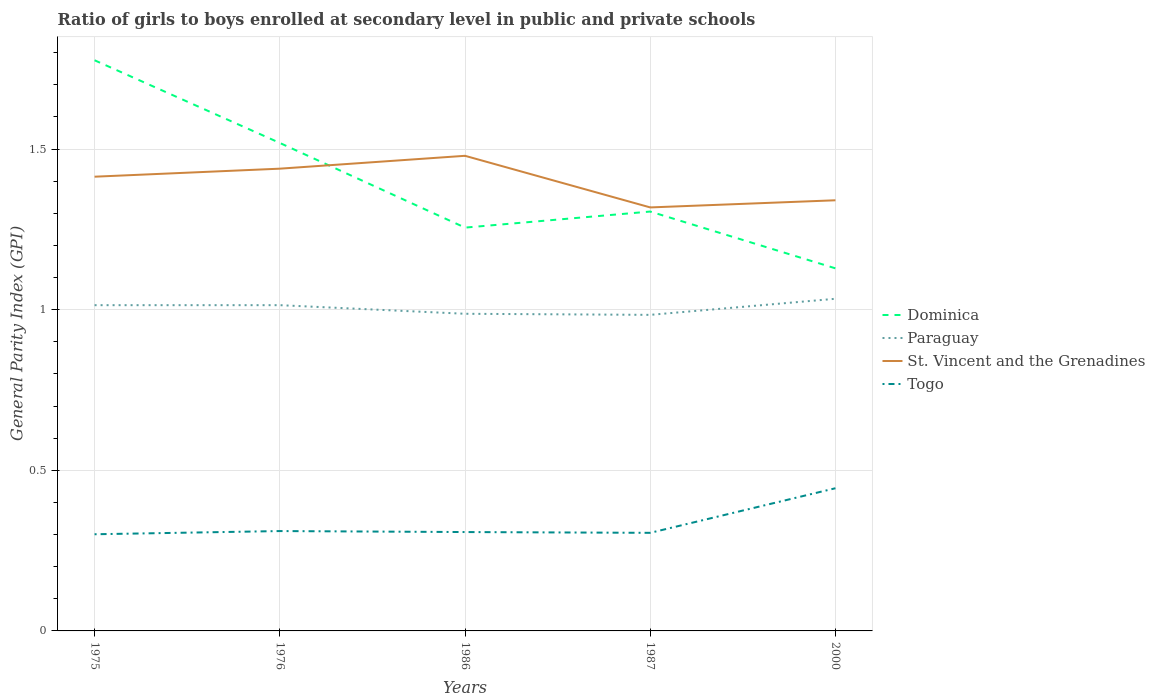Does the line corresponding to Paraguay intersect with the line corresponding to St. Vincent and the Grenadines?
Provide a short and direct response. No. Is the number of lines equal to the number of legend labels?
Ensure brevity in your answer.  Yes. Across all years, what is the maximum general parity index in Dominica?
Make the answer very short. 1.13. What is the total general parity index in Togo in the graph?
Make the answer very short. 0. What is the difference between the highest and the second highest general parity index in Togo?
Your answer should be compact. 0.14. Is the general parity index in Togo strictly greater than the general parity index in Paraguay over the years?
Ensure brevity in your answer.  Yes. How many lines are there?
Offer a very short reply. 4. How many years are there in the graph?
Keep it short and to the point. 5. Are the values on the major ticks of Y-axis written in scientific E-notation?
Your answer should be compact. No. Does the graph contain grids?
Make the answer very short. Yes. Where does the legend appear in the graph?
Keep it short and to the point. Center right. How many legend labels are there?
Give a very brief answer. 4. How are the legend labels stacked?
Provide a succinct answer. Vertical. What is the title of the graph?
Your answer should be very brief. Ratio of girls to boys enrolled at secondary level in public and private schools. What is the label or title of the Y-axis?
Offer a terse response. General Parity Index (GPI). What is the General Parity Index (GPI) in Dominica in 1975?
Keep it short and to the point. 1.78. What is the General Parity Index (GPI) in Paraguay in 1975?
Your answer should be compact. 1.01. What is the General Parity Index (GPI) of St. Vincent and the Grenadines in 1975?
Offer a very short reply. 1.41. What is the General Parity Index (GPI) of Togo in 1975?
Keep it short and to the point. 0.3. What is the General Parity Index (GPI) of Dominica in 1976?
Your answer should be compact. 1.52. What is the General Parity Index (GPI) in Paraguay in 1976?
Provide a short and direct response. 1.01. What is the General Parity Index (GPI) in St. Vincent and the Grenadines in 1976?
Keep it short and to the point. 1.44. What is the General Parity Index (GPI) of Togo in 1976?
Ensure brevity in your answer.  0.31. What is the General Parity Index (GPI) in Dominica in 1986?
Your response must be concise. 1.26. What is the General Parity Index (GPI) of Paraguay in 1986?
Your answer should be very brief. 0.99. What is the General Parity Index (GPI) in St. Vincent and the Grenadines in 1986?
Provide a short and direct response. 1.48. What is the General Parity Index (GPI) of Togo in 1986?
Provide a succinct answer. 0.31. What is the General Parity Index (GPI) in Dominica in 1987?
Provide a short and direct response. 1.31. What is the General Parity Index (GPI) in Paraguay in 1987?
Offer a terse response. 0.98. What is the General Parity Index (GPI) of St. Vincent and the Grenadines in 1987?
Your answer should be compact. 1.32. What is the General Parity Index (GPI) in Togo in 1987?
Offer a very short reply. 0.31. What is the General Parity Index (GPI) in Dominica in 2000?
Your answer should be very brief. 1.13. What is the General Parity Index (GPI) of Paraguay in 2000?
Keep it short and to the point. 1.03. What is the General Parity Index (GPI) of St. Vincent and the Grenadines in 2000?
Offer a terse response. 1.34. What is the General Parity Index (GPI) in Togo in 2000?
Offer a terse response. 0.44. Across all years, what is the maximum General Parity Index (GPI) of Dominica?
Make the answer very short. 1.78. Across all years, what is the maximum General Parity Index (GPI) in Paraguay?
Your answer should be compact. 1.03. Across all years, what is the maximum General Parity Index (GPI) of St. Vincent and the Grenadines?
Your answer should be very brief. 1.48. Across all years, what is the maximum General Parity Index (GPI) in Togo?
Your answer should be very brief. 0.44. Across all years, what is the minimum General Parity Index (GPI) in Dominica?
Give a very brief answer. 1.13. Across all years, what is the minimum General Parity Index (GPI) of Paraguay?
Your answer should be very brief. 0.98. Across all years, what is the minimum General Parity Index (GPI) of St. Vincent and the Grenadines?
Keep it short and to the point. 1.32. Across all years, what is the minimum General Parity Index (GPI) of Togo?
Ensure brevity in your answer.  0.3. What is the total General Parity Index (GPI) of Dominica in the graph?
Provide a short and direct response. 6.99. What is the total General Parity Index (GPI) of Paraguay in the graph?
Provide a short and direct response. 5.03. What is the total General Parity Index (GPI) in St. Vincent and the Grenadines in the graph?
Offer a very short reply. 6.99. What is the total General Parity Index (GPI) in Togo in the graph?
Offer a very short reply. 1.67. What is the difference between the General Parity Index (GPI) in Dominica in 1975 and that in 1976?
Make the answer very short. 0.26. What is the difference between the General Parity Index (GPI) of Paraguay in 1975 and that in 1976?
Offer a terse response. 0. What is the difference between the General Parity Index (GPI) of St. Vincent and the Grenadines in 1975 and that in 1976?
Offer a very short reply. -0.03. What is the difference between the General Parity Index (GPI) of Togo in 1975 and that in 1976?
Provide a short and direct response. -0.01. What is the difference between the General Parity Index (GPI) of Dominica in 1975 and that in 1986?
Your response must be concise. 0.52. What is the difference between the General Parity Index (GPI) in Paraguay in 1975 and that in 1986?
Your response must be concise. 0.03. What is the difference between the General Parity Index (GPI) in St. Vincent and the Grenadines in 1975 and that in 1986?
Provide a short and direct response. -0.07. What is the difference between the General Parity Index (GPI) in Togo in 1975 and that in 1986?
Your response must be concise. -0.01. What is the difference between the General Parity Index (GPI) of Dominica in 1975 and that in 1987?
Give a very brief answer. 0.47. What is the difference between the General Parity Index (GPI) of Paraguay in 1975 and that in 1987?
Offer a terse response. 0.03. What is the difference between the General Parity Index (GPI) in St. Vincent and the Grenadines in 1975 and that in 1987?
Your answer should be very brief. 0.1. What is the difference between the General Parity Index (GPI) in Togo in 1975 and that in 1987?
Your response must be concise. -0. What is the difference between the General Parity Index (GPI) in Dominica in 1975 and that in 2000?
Provide a short and direct response. 0.65. What is the difference between the General Parity Index (GPI) of Paraguay in 1975 and that in 2000?
Give a very brief answer. -0.02. What is the difference between the General Parity Index (GPI) in St. Vincent and the Grenadines in 1975 and that in 2000?
Ensure brevity in your answer.  0.07. What is the difference between the General Parity Index (GPI) in Togo in 1975 and that in 2000?
Make the answer very short. -0.14. What is the difference between the General Parity Index (GPI) of Dominica in 1976 and that in 1986?
Your answer should be compact. 0.26. What is the difference between the General Parity Index (GPI) of Paraguay in 1976 and that in 1986?
Your response must be concise. 0.03. What is the difference between the General Parity Index (GPI) in St. Vincent and the Grenadines in 1976 and that in 1986?
Offer a very short reply. -0.04. What is the difference between the General Parity Index (GPI) in Togo in 1976 and that in 1986?
Provide a succinct answer. 0. What is the difference between the General Parity Index (GPI) in Dominica in 1976 and that in 1987?
Provide a succinct answer. 0.21. What is the difference between the General Parity Index (GPI) in Paraguay in 1976 and that in 1987?
Offer a terse response. 0.03. What is the difference between the General Parity Index (GPI) in St. Vincent and the Grenadines in 1976 and that in 1987?
Ensure brevity in your answer.  0.12. What is the difference between the General Parity Index (GPI) in Togo in 1976 and that in 1987?
Ensure brevity in your answer.  0.01. What is the difference between the General Parity Index (GPI) of Dominica in 1976 and that in 2000?
Your answer should be compact. 0.39. What is the difference between the General Parity Index (GPI) of Paraguay in 1976 and that in 2000?
Provide a succinct answer. -0.02. What is the difference between the General Parity Index (GPI) in St. Vincent and the Grenadines in 1976 and that in 2000?
Provide a succinct answer. 0.1. What is the difference between the General Parity Index (GPI) in Togo in 1976 and that in 2000?
Ensure brevity in your answer.  -0.13. What is the difference between the General Parity Index (GPI) of Dominica in 1986 and that in 1987?
Provide a short and direct response. -0.05. What is the difference between the General Parity Index (GPI) of Paraguay in 1986 and that in 1987?
Your response must be concise. 0. What is the difference between the General Parity Index (GPI) in St. Vincent and the Grenadines in 1986 and that in 1987?
Provide a succinct answer. 0.16. What is the difference between the General Parity Index (GPI) of Togo in 1986 and that in 1987?
Offer a very short reply. 0. What is the difference between the General Parity Index (GPI) in Dominica in 1986 and that in 2000?
Offer a very short reply. 0.13. What is the difference between the General Parity Index (GPI) in Paraguay in 1986 and that in 2000?
Provide a succinct answer. -0.05. What is the difference between the General Parity Index (GPI) in St. Vincent and the Grenadines in 1986 and that in 2000?
Give a very brief answer. 0.14. What is the difference between the General Parity Index (GPI) of Togo in 1986 and that in 2000?
Your answer should be compact. -0.14. What is the difference between the General Parity Index (GPI) in Dominica in 1987 and that in 2000?
Your response must be concise. 0.18. What is the difference between the General Parity Index (GPI) in Paraguay in 1987 and that in 2000?
Your response must be concise. -0.05. What is the difference between the General Parity Index (GPI) of St. Vincent and the Grenadines in 1987 and that in 2000?
Offer a very short reply. -0.02. What is the difference between the General Parity Index (GPI) of Togo in 1987 and that in 2000?
Your answer should be compact. -0.14. What is the difference between the General Parity Index (GPI) in Dominica in 1975 and the General Parity Index (GPI) in Paraguay in 1976?
Your answer should be compact. 0.76. What is the difference between the General Parity Index (GPI) in Dominica in 1975 and the General Parity Index (GPI) in St. Vincent and the Grenadines in 1976?
Your answer should be compact. 0.34. What is the difference between the General Parity Index (GPI) of Dominica in 1975 and the General Parity Index (GPI) of Togo in 1976?
Make the answer very short. 1.47. What is the difference between the General Parity Index (GPI) in Paraguay in 1975 and the General Parity Index (GPI) in St. Vincent and the Grenadines in 1976?
Give a very brief answer. -0.42. What is the difference between the General Parity Index (GPI) of Paraguay in 1975 and the General Parity Index (GPI) of Togo in 1976?
Provide a short and direct response. 0.7. What is the difference between the General Parity Index (GPI) of St. Vincent and the Grenadines in 1975 and the General Parity Index (GPI) of Togo in 1976?
Offer a very short reply. 1.1. What is the difference between the General Parity Index (GPI) in Dominica in 1975 and the General Parity Index (GPI) in Paraguay in 1986?
Your answer should be compact. 0.79. What is the difference between the General Parity Index (GPI) of Dominica in 1975 and the General Parity Index (GPI) of St. Vincent and the Grenadines in 1986?
Keep it short and to the point. 0.3. What is the difference between the General Parity Index (GPI) in Dominica in 1975 and the General Parity Index (GPI) in Togo in 1986?
Ensure brevity in your answer.  1.47. What is the difference between the General Parity Index (GPI) of Paraguay in 1975 and the General Parity Index (GPI) of St. Vincent and the Grenadines in 1986?
Offer a terse response. -0.47. What is the difference between the General Parity Index (GPI) of Paraguay in 1975 and the General Parity Index (GPI) of Togo in 1986?
Keep it short and to the point. 0.71. What is the difference between the General Parity Index (GPI) in St. Vincent and the Grenadines in 1975 and the General Parity Index (GPI) in Togo in 1986?
Ensure brevity in your answer.  1.11. What is the difference between the General Parity Index (GPI) in Dominica in 1975 and the General Parity Index (GPI) in Paraguay in 1987?
Keep it short and to the point. 0.79. What is the difference between the General Parity Index (GPI) in Dominica in 1975 and the General Parity Index (GPI) in St. Vincent and the Grenadines in 1987?
Give a very brief answer. 0.46. What is the difference between the General Parity Index (GPI) of Dominica in 1975 and the General Parity Index (GPI) of Togo in 1987?
Make the answer very short. 1.47. What is the difference between the General Parity Index (GPI) of Paraguay in 1975 and the General Parity Index (GPI) of St. Vincent and the Grenadines in 1987?
Your answer should be compact. -0.3. What is the difference between the General Parity Index (GPI) in Paraguay in 1975 and the General Parity Index (GPI) in Togo in 1987?
Offer a terse response. 0.71. What is the difference between the General Parity Index (GPI) in St. Vincent and the Grenadines in 1975 and the General Parity Index (GPI) in Togo in 1987?
Ensure brevity in your answer.  1.11. What is the difference between the General Parity Index (GPI) of Dominica in 1975 and the General Parity Index (GPI) of Paraguay in 2000?
Provide a short and direct response. 0.74. What is the difference between the General Parity Index (GPI) in Dominica in 1975 and the General Parity Index (GPI) in St. Vincent and the Grenadines in 2000?
Make the answer very short. 0.44. What is the difference between the General Parity Index (GPI) in Dominica in 1975 and the General Parity Index (GPI) in Togo in 2000?
Your answer should be very brief. 1.33. What is the difference between the General Parity Index (GPI) of Paraguay in 1975 and the General Parity Index (GPI) of St. Vincent and the Grenadines in 2000?
Give a very brief answer. -0.33. What is the difference between the General Parity Index (GPI) of Paraguay in 1975 and the General Parity Index (GPI) of Togo in 2000?
Your answer should be compact. 0.57. What is the difference between the General Parity Index (GPI) of St. Vincent and the Grenadines in 1975 and the General Parity Index (GPI) of Togo in 2000?
Your response must be concise. 0.97. What is the difference between the General Parity Index (GPI) of Dominica in 1976 and the General Parity Index (GPI) of Paraguay in 1986?
Offer a terse response. 0.53. What is the difference between the General Parity Index (GPI) of Dominica in 1976 and the General Parity Index (GPI) of Togo in 1986?
Make the answer very short. 1.21. What is the difference between the General Parity Index (GPI) of Paraguay in 1976 and the General Parity Index (GPI) of St. Vincent and the Grenadines in 1986?
Make the answer very short. -0.47. What is the difference between the General Parity Index (GPI) of Paraguay in 1976 and the General Parity Index (GPI) of Togo in 1986?
Offer a very short reply. 0.71. What is the difference between the General Parity Index (GPI) in St. Vincent and the Grenadines in 1976 and the General Parity Index (GPI) in Togo in 1986?
Ensure brevity in your answer.  1.13. What is the difference between the General Parity Index (GPI) in Dominica in 1976 and the General Parity Index (GPI) in Paraguay in 1987?
Provide a short and direct response. 0.54. What is the difference between the General Parity Index (GPI) of Dominica in 1976 and the General Parity Index (GPI) of St. Vincent and the Grenadines in 1987?
Make the answer very short. 0.2. What is the difference between the General Parity Index (GPI) of Dominica in 1976 and the General Parity Index (GPI) of Togo in 1987?
Your response must be concise. 1.21. What is the difference between the General Parity Index (GPI) in Paraguay in 1976 and the General Parity Index (GPI) in St. Vincent and the Grenadines in 1987?
Your answer should be very brief. -0.3. What is the difference between the General Parity Index (GPI) of Paraguay in 1976 and the General Parity Index (GPI) of Togo in 1987?
Provide a succinct answer. 0.71. What is the difference between the General Parity Index (GPI) of St. Vincent and the Grenadines in 1976 and the General Parity Index (GPI) of Togo in 1987?
Provide a short and direct response. 1.13. What is the difference between the General Parity Index (GPI) of Dominica in 1976 and the General Parity Index (GPI) of Paraguay in 2000?
Provide a short and direct response. 0.49. What is the difference between the General Parity Index (GPI) in Dominica in 1976 and the General Parity Index (GPI) in St. Vincent and the Grenadines in 2000?
Make the answer very short. 0.18. What is the difference between the General Parity Index (GPI) in Dominica in 1976 and the General Parity Index (GPI) in Togo in 2000?
Give a very brief answer. 1.07. What is the difference between the General Parity Index (GPI) of Paraguay in 1976 and the General Parity Index (GPI) of St. Vincent and the Grenadines in 2000?
Keep it short and to the point. -0.33. What is the difference between the General Parity Index (GPI) of Paraguay in 1976 and the General Parity Index (GPI) of Togo in 2000?
Provide a short and direct response. 0.57. What is the difference between the General Parity Index (GPI) in St. Vincent and the Grenadines in 1976 and the General Parity Index (GPI) in Togo in 2000?
Provide a succinct answer. 0.99. What is the difference between the General Parity Index (GPI) in Dominica in 1986 and the General Parity Index (GPI) in Paraguay in 1987?
Offer a terse response. 0.27. What is the difference between the General Parity Index (GPI) in Dominica in 1986 and the General Parity Index (GPI) in St. Vincent and the Grenadines in 1987?
Offer a terse response. -0.06. What is the difference between the General Parity Index (GPI) of Dominica in 1986 and the General Parity Index (GPI) of Togo in 1987?
Give a very brief answer. 0.95. What is the difference between the General Parity Index (GPI) in Paraguay in 1986 and the General Parity Index (GPI) in St. Vincent and the Grenadines in 1987?
Your response must be concise. -0.33. What is the difference between the General Parity Index (GPI) in Paraguay in 1986 and the General Parity Index (GPI) in Togo in 1987?
Your answer should be very brief. 0.68. What is the difference between the General Parity Index (GPI) of St. Vincent and the Grenadines in 1986 and the General Parity Index (GPI) of Togo in 1987?
Make the answer very short. 1.17. What is the difference between the General Parity Index (GPI) in Dominica in 1986 and the General Parity Index (GPI) in Paraguay in 2000?
Ensure brevity in your answer.  0.22. What is the difference between the General Parity Index (GPI) in Dominica in 1986 and the General Parity Index (GPI) in St. Vincent and the Grenadines in 2000?
Provide a short and direct response. -0.09. What is the difference between the General Parity Index (GPI) in Dominica in 1986 and the General Parity Index (GPI) in Togo in 2000?
Make the answer very short. 0.81. What is the difference between the General Parity Index (GPI) of Paraguay in 1986 and the General Parity Index (GPI) of St. Vincent and the Grenadines in 2000?
Provide a succinct answer. -0.35. What is the difference between the General Parity Index (GPI) in Paraguay in 1986 and the General Parity Index (GPI) in Togo in 2000?
Provide a succinct answer. 0.54. What is the difference between the General Parity Index (GPI) in St. Vincent and the Grenadines in 1986 and the General Parity Index (GPI) in Togo in 2000?
Your response must be concise. 1.03. What is the difference between the General Parity Index (GPI) in Dominica in 1987 and the General Parity Index (GPI) in Paraguay in 2000?
Your answer should be very brief. 0.27. What is the difference between the General Parity Index (GPI) in Dominica in 1987 and the General Parity Index (GPI) in St. Vincent and the Grenadines in 2000?
Provide a succinct answer. -0.04. What is the difference between the General Parity Index (GPI) in Dominica in 1987 and the General Parity Index (GPI) in Togo in 2000?
Your response must be concise. 0.86. What is the difference between the General Parity Index (GPI) of Paraguay in 1987 and the General Parity Index (GPI) of St. Vincent and the Grenadines in 2000?
Offer a terse response. -0.36. What is the difference between the General Parity Index (GPI) of Paraguay in 1987 and the General Parity Index (GPI) of Togo in 2000?
Offer a very short reply. 0.54. What is the difference between the General Parity Index (GPI) of St. Vincent and the Grenadines in 1987 and the General Parity Index (GPI) of Togo in 2000?
Give a very brief answer. 0.87. What is the average General Parity Index (GPI) in Dominica per year?
Offer a very short reply. 1.4. What is the average General Parity Index (GPI) of St. Vincent and the Grenadines per year?
Provide a short and direct response. 1.4. What is the average General Parity Index (GPI) of Togo per year?
Give a very brief answer. 0.33. In the year 1975, what is the difference between the General Parity Index (GPI) in Dominica and General Parity Index (GPI) in Paraguay?
Your response must be concise. 0.76. In the year 1975, what is the difference between the General Parity Index (GPI) in Dominica and General Parity Index (GPI) in St. Vincent and the Grenadines?
Give a very brief answer. 0.36. In the year 1975, what is the difference between the General Parity Index (GPI) in Dominica and General Parity Index (GPI) in Togo?
Provide a short and direct response. 1.48. In the year 1975, what is the difference between the General Parity Index (GPI) of Paraguay and General Parity Index (GPI) of Togo?
Keep it short and to the point. 0.71. In the year 1975, what is the difference between the General Parity Index (GPI) of St. Vincent and the Grenadines and General Parity Index (GPI) of Togo?
Offer a very short reply. 1.11. In the year 1976, what is the difference between the General Parity Index (GPI) in Dominica and General Parity Index (GPI) in Paraguay?
Your response must be concise. 0.51. In the year 1976, what is the difference between the General Parity Index (GPI) of Dominica and General Parity Index (GPI) of St. Vincent and the Grenadines?
Your response must be concise. 0.08. In the year 1976, what is the difference between the General Parity Index (GPI) in Dominica and General Parity Index (GPI) in Togo?
Provide a succinct answer. 1.21. In the year 1976, what is the difference between the General Parity Index (GPI) of Paraguay and General Parity Index (GPI) of St. Vincent and the Grenadines?
Your answer should be compact. -0.42. In the year 1976, what is the difference between the General Parity Index (GPI) of Paraguay and General Parity Index (GPI) of Togo?
Your response must be concise. 0.7. In the year 1976, what is the difference between the General Parity Index (GPI) in St. Vincent and the Grenadines and General Parity Index (GPI) in Togo?
Offer a terse response. 1.13. In the year 1986, what is the difference between the General Parity Index (GPI) in Dominica and General Parity Index (GPI) in Paraguay?
Your response must be concise. 0.27. In the year 1986, what is the difference between the General Parity Index (GPI) in Dominica and General Parity Index (GPI) in St. Vincent and the Grenadines?
Provide a succinct answer. -0.22. In the year 1986, what is the difference between the General Parity Index (GPI) of Dominica and General Parity Index (GPI) of Togo?
Offer a very short reply. 0.95. In the year 1986, what is the difference between the General Parity Index (GPI) of Paraguay and General Parity Index (GPI) of St. Vincent and the Grenadines?
Provide a short and direct response. -0.49. In the year 1986, what is the difference between the General Parity Index (GPI) of Paraguay and General Parity Index (GPI) of Togo?
Ensure brevity in your answer.  0.68. In the year 1986, what is the difference between the General Parity Index (GPI) in St. Vincent and the Grenadines and General Parity Index (GPI) in Togo?
Make the answer very short. 1.17. In the year 1987, what is the difference between the General Parity Index (GPI) in Dominica and General Parity Index (GPI) in Paraguay?
Offer a very short reply. 0.32. In the year 1987, what is the difference between the General Parity Index (GPI) of Dominica and General Parity Index (GPI) of St. Vincent and the Grenadines?
Keep it short and to the point. -0.01. In the year 1987, what is the difference between the General Parity Index (GPI) of Paraguay and General Parity Index (GPI) of St. Vincent and the Grenadines?
Your answer should be very brief. -0.33. In the year 1987, what is the difference between the General Parity Index (GPI) in Paraguay and General Parity Index (GPI) in Togo?
Make the answer very short. 0.68. In the year 1987, what is the difference between the General Parity Index (GPI) in St. Vincent and the Grenadines and General Parity Index (GPI) in Togo?
Ensure brevity in your answer.  1.01. In the year 2000, what is the difference between the General Parity Index (GPI) in Dominica and General Parity Index (GPI) in Paraguay?
Offer a very short reply. 0.09. In the year 2000, what is the difference between the General Parity Index (GPI) of Dominica and General Parity Index (GPI) of St. Vincent and the Grenadines?
Your response must be concise. -0.21. In the year 2000, what is the difference between the General Parity Index (GPI) of Dominica and General Parity Index (GPI) of Togo?
Your response must be concise. 0.68. In the year 2000, what is the difference between the General Parity Index (GPI) of Paraguay and General Parity Index (GPI) of St. Vincent and the Grenadines?
Make the answer very short. -0.31. In the year 2000, what is the difference between the General Parity Index (GPI) of Paraguay and General Parity Index (GPI) of Togo?
Ensure brevity in your answer.  0.59. In the year 2000, what is the difference between the General Parity Index (GPI) of St. Vincent and the Grenadines and General Parity Index (GPI) of Togo?
Keep it short and to the point. 0.9. What is the ratio of the General Parity Index (GPI) in Dominica in 1975 to that in 1976?
Offer a very short reply. 1.17. What is the ratio of the General Parity Index (GPI) in St. Vincent and the Grenadines in 1975 to that in 1976?
Provide a short and direct response. 0.98. What is the ratio of the General Parity Index (GPI) in Dominica in 1975 to that in 1986?
Your response must be concise. 1.41. What is the ratio of the General Parity Index (GPI) of Paraguay in 1975 to that in 1986?
Your response must be concise. 1.03. What is the ratio of the General Parity Index (GPI) in St. Vincent and the Grenadines in 1975 to that in 1986?
Your answer should be compact. 0.96. What is the ratio of the General Parity Index (GPI) of Togo in 1975 to that in 1986?
Offer a very short reply. 0.98. What is the ratio of the General Parity Index (GPI) in Dominica in 1975 to that in 1987?
Your response must be concise. 1.36. What is the ratio of the General Parity Index (GPI) in Paraguay in 1975 to that in 1987?
Provide a succinct answer. 1.03. What is the ratio of the General Parity Index (GPI) of St. Vincent and the Grenadines in 1975 to that in 1987?
Make the answer very short. 1.07. What is the ratio of the General Parity Index (GPI) in Togo in 1975 to that in 1987?
Keep it short and to the point. 0.99. What is the ratio of the General Parity Index (GPI) of Dominica in 1975 to that in 2000?
Offer a terse response. 1.57. What is the ratio of the General Parity Index (GPI) of Paraguay in 1975 to that in 2000?
Keep it short and to the point. 0.98. What is the ratio of the General Parity Index (GPI) in St. Vincent and the Grenadines in 1975 to that in 2000?
Offer a very short reply. 1.05. What is the ratio of the General Parity Index (GPI) of Togo in 1975 to that in 2000?
Give a very brief answer. 0.68. What is the ratio of the General Parity Index (GPI) in Dominica in 1976 to that in 1986?
Provide a succinct answer. 1.21. What is the ratio of the General Parity Index (GPI) in Paraguay in 1976 to that in 1986?
Make the answer very short. 1.03. What is the ratio of the General Parity Index (GPI) of St. Vincent and the Grenadines in 1976 to that in 1986?
Ensure brevity in your answer.  0.97. What is the ratio of the General Parity Index (GPI) of Dominica in 1976 to that in 1987?
Ensure brevity in your answer.  1.16. What is the ratio of the General Parity Index (GPI) in Paraguay in 1976 to that in 1987?
Give a very brief answer. 1.03. What is the ratio of the General Parity Index (GPI) of St. Vincent and the Grenadines in 1976 to that in 1987?
Give a very brief answer. 1.09. What is the ratio of the General Parity Index (GPI) of Togo in 1976 to that in 1987?
Your answer should be very brief. 1.02. What is the ratio of the General Parity Index (GPI) of Dominica in 1976 to that in 2000?
Offer a very short reply. 1.35. What is the ratio of the General Parity Index (GPI) of Paraguay in 1976 to that in 2000?
Provide a succinct answer. 0.98. What is the ratio of the General Parity Index (GPI) in St. Vincent and the Grenadines in 1976 to that in 2000?
Give a very brief answer. 1.07. What is the ratio of the General Parity Index (GPI) in Togo in 1976 to that in 2000?
Your answer should be very brief. 0.7. What is the ratio of the General Parity Index (GPI) of Dominica in 1986 to that in 1987?
Your response must be concise. 0.96. What is the ratio of the General Parity Index (GPI) of St. Vincent and the Grenadines in 1986 to that in 1987?
Ensure brevity in your answer.  1.12. What is the ratio of the General Parity Index (GPI) in Togo in 1986 to that in 1987?
Ensure brevity in your answer.  1.01. What is the ratio of the General Parity Index (GPI) in Dominica in 1986 to that in 2000?
Offer a very short reply. 1.11. What is the ratio of the General Parity Index (GPI) of Paraguay in 1986 to that in 2000?
Ensure brevity in your answer.  0.95. What is the ratio of the General Parity Index (GPI) in St. Vincent and the Grenadines in 1986 to that in 2000?
Your response must be concise. 1.1. What is the ratio of the General Parity Index (GPI) in Togo in 1986 to that in 2000?
Provide a succinct answer. 0.69. What is the ratio of the General Parity Index (GPI) in Dominica in 1987 to that in 2000?
Provide a short and direct response. 1.16. What is the ratio of the General Parity Index (GPI) in Paraguay in 1987 to that in 2000?
Your answer should be compact. 0.95. What is the ratio of the General Parity Index (GPI) of St. Vincent and the Grenadines in 1987 to that in 2000?
Make the answer very short. 0.98. What is the ratio of the General Parity Index (GPI) of Togo in 1987 to that in 2000?
Make the answer very short. 0.69. What is the difference between the highest and the second highest General Parity Index (GPI) in Dominica?
Your answer should be compact. 0.26. What is the difference between the highest and the second highest General Parity Index (GPI) of Paraguay?
Offer a terse response. 0.02. What is the difference between the highest and the second highest General Parity Index (GPI) in St. Vincent and the Grenadines?
Offer a terse response. 0.04. What is the difference between the highest and the second highest General Parity Index (GPI) in Togo?
Provide a succinct answer. 0.13. What is the difference between the highest and the lowest General Parity Index (GPI) in Dominica?
Provide a short and direct response. 0.65. What is the difference between the highest and the lowest General Parity Index (GPI) of Paraguay?
Your response must be concise. 0.05. What is the difference between the highest and the lowest General Parity Index (GPI) in St. Vincent and the Grenadines?
Keep it short and to the point. 0.16. What is the difference between the highest and the lowest General Parity Index (GPI) in Togo?
Provide a short and direct response. 0.14. 